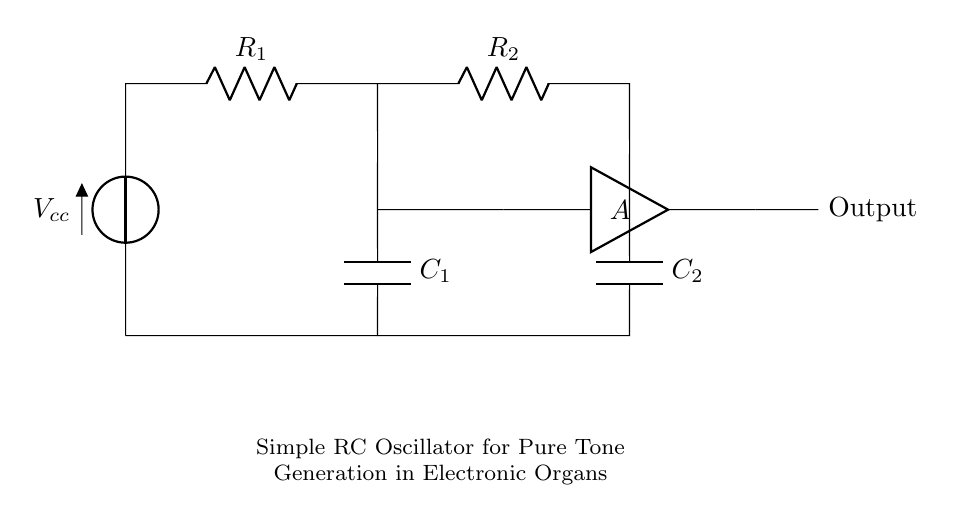What is the type of voltage source used in the circuit? The circuit uses a DC voltage source, indicated by the symbol V with a label Vcc. This represents a constant voltage supply.
Answer: DC How many resistors are present in the circuit? There are two resistors in the circuit, labeled R1 and R2, which are both essential for controlling the timing of oscillation.
Answer: 2 What component is responsible for generating the oscillating signals? The operational amplifier, indicated by the symbol A, works as a feedback device to sustain oscillation with the help of resistors and capacitors.
Answer: Amplifier What is the role of capacitors in this oscillator circuit? Capacitors C1 and C2 store energy and determine timing, influencing the frequency of oscillation based on their values along with the resistors.
Answer: Timing What is the output of this circuit? The output is indicated as a simple output connection, where the generated pure tone signal can be taken out to drive other circuit elements or speakers.
Answer: Output 